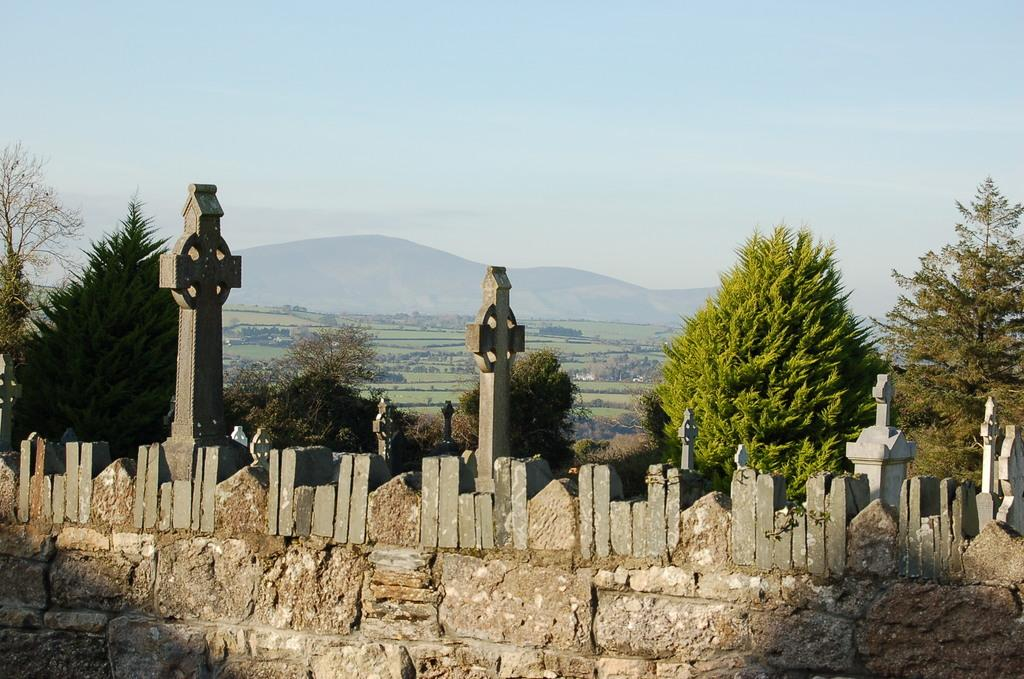What type of structure can be seen in the image? There is a wall in the image. Are there any architectural features supporting the wall? Yes, there are pillars in the image. What can be seen in the background of the image? There are many trees, mountains, and the sky visible in the background of the image. What is the ground like in the image? The ground is visible in the background of the image. How many cents are visible on the wall in the image? There are no cents present in the image; it features a wall with pillars and a background with trees, mountains, and the sky. Can you see any sheep in the image? There are no sheep present in the image. 